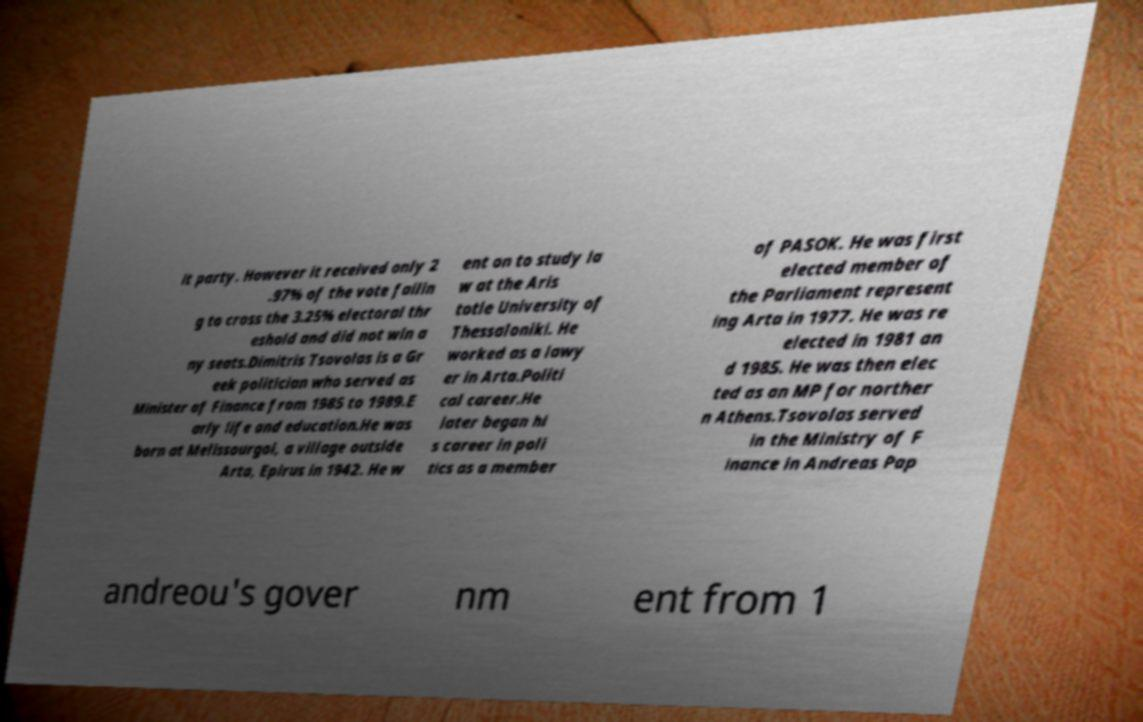I need the written content from this picture converted into text. Can you do that? it party. However it received only 2 .97% of the vote failin g to cross the 3.25% electoral thr eshold and did not win a ny seats.Dimitris Tsovolas is a Gr eek politician who served as Minister of Finance from 1985 to 1989.E arly life and education.He was born at Melissourgoi, a village outside Arta, Epirus in 1942. He w ent on to study la w at the Aris totle University of Thessaloniki. He worked as a lawy er in Arta.Politi cal career.He later began hi s career in poli tics as a member of PASOK. He was first elected member of the Parliament represent ing Arta in 1977. He was re elected in 1981 an d 1985. He was then elec ted as an MP for norther n Athens.Tsovolas served in the Ministry of F inance in Andreas Pap andreou's gover nm ent from 1 